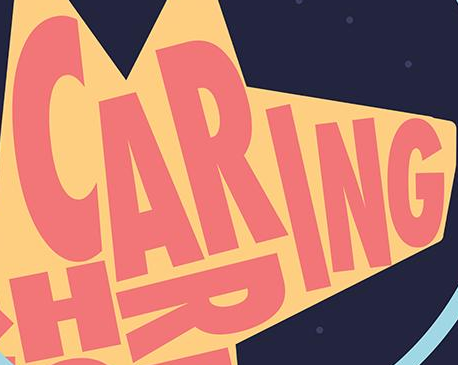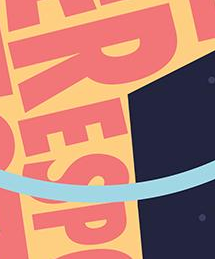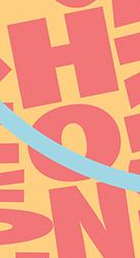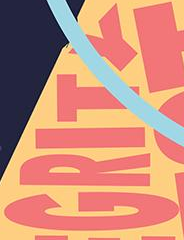Read the text content from these images in order, separated by a semicolon. CARING; RESP; HON; GRITY 